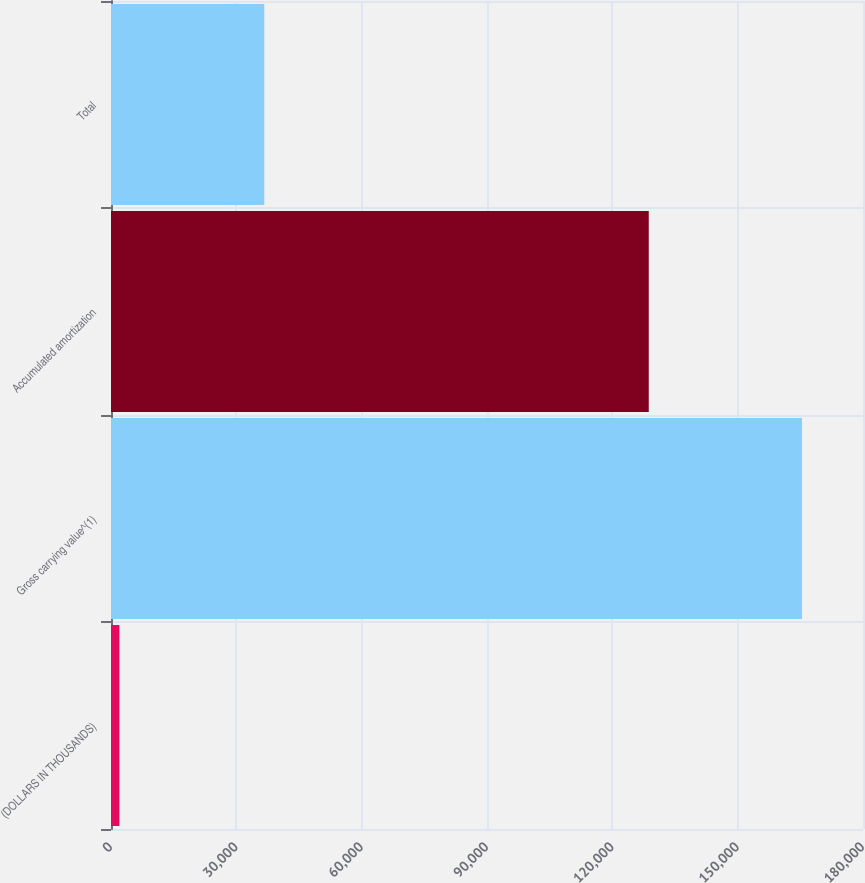Convert chart. <chart><loc_0><loc_0><loc_500><loc_500><bar_chart><fcel>(DOLLARS IN THOUSANDS)<fcel>Gross carrying value^(1)<fcel>Accumulated amortization<fcel>Total<nl><fcel>2012<fcel>165406<fcel>128718<fcel>36688<nl></chart> 